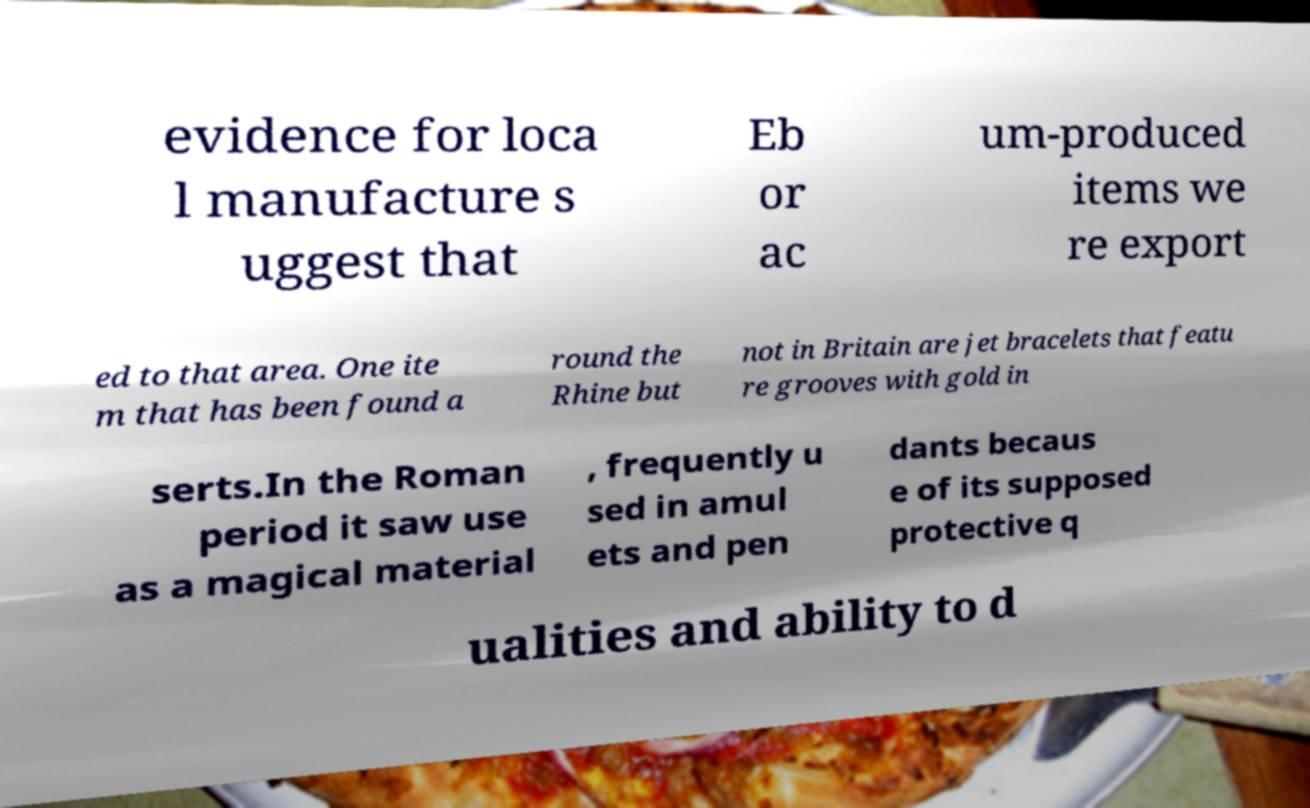Please identify and transcribe the text found in this image. evidence for loca l manufacture s uggest that Eb or ac um-produced items we re export ed to that area. One ite m that has been found a round the Rhine but not in Britain are jet bracelets that featu re grooves with gold in serts.In the Roman period it saw use as a magical material , frequently u sed in amul ets and pen dants becaus e of its supposed protective q ualities and ability to d 